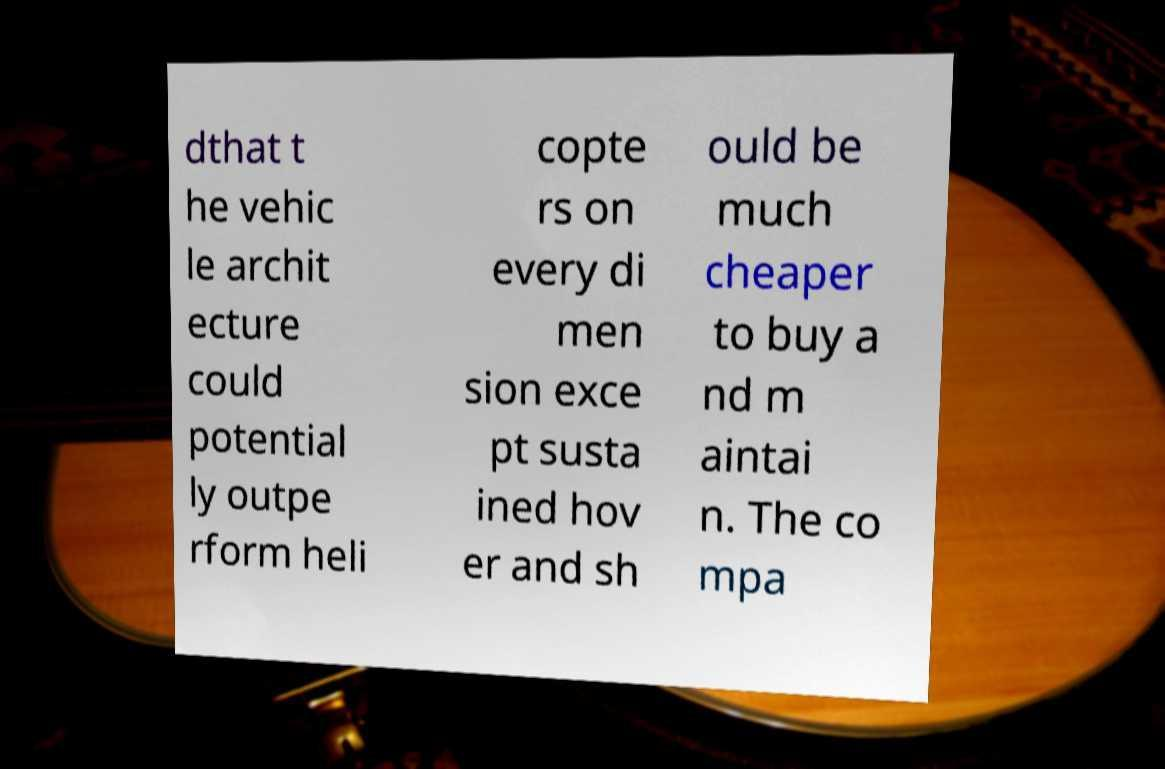Can you read and provide the text displayed in the image?This photo seems to have some interesting text. Can you extract and type it out for me? dthat t he vehic le archit ecture could potential ly outpe rform heli copte rs on every di men sion exce pt susta ined hov er and sh ould be much cheaper to buy a nd m aintai n. The co mpa 